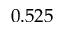Convert formula to latex. <formula><loc_0><loc_0><loc_500><loc_500>0 . 5 2 5</formula> 